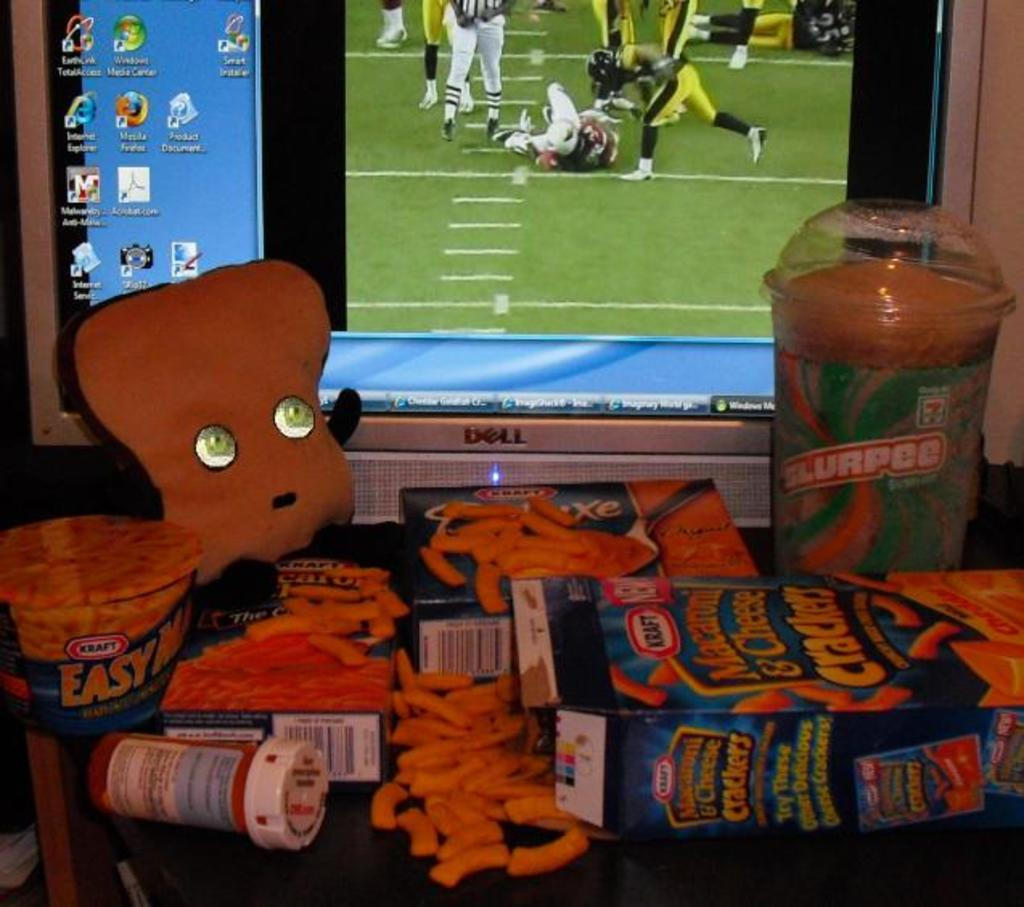Provide a one-sentence caption for the provided image. Boxes of Kraft mac'n cheese are in front of a computer monitor. 